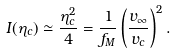<formula> <loc_0><loc_0><loc_500><loc_500>I ( \eta _ { c } ) \simeq \frac { \eta _ { c } ^ { 2 } } { 4 } = \frac { 1 } { f _ { M } } \left ( \frac { v _ { \infty } } { v _ { c } } \right ) ^ { 2 } .</formula> 